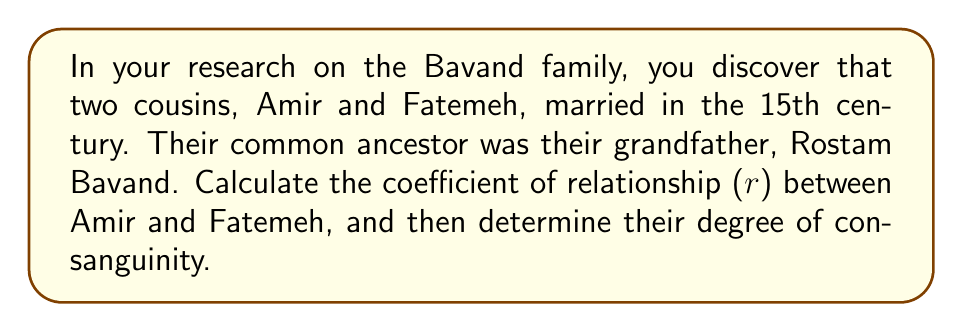Can you solve this math problem? To solve this problem, we'll follow these steps:

1) First, let's calculate the coefficient of relationship (r) between Amir and Fatemeh.

2) The coefficient of relationship is calculated using the formula:

   $$r = \sum (\frac{1}{2})^{n_1 + n_2 + 1}$$

   Where $n_1$ is the number of generations from one individual to the common ancestor, and $n_2$ is the number of generations from the other individual to the common ancestor.

3) In this case, both Amir and Fatemeh are two generations away from their common ancestor (grandfather Rostam Bavand). So $n_1 = n_2 = 2$.

4) Plugging these values into the formula:

   $$r = (\frac{1}{2})^{2 + 2 + 1} = (\frac{1}{2})^5 = \frac{1}{32} = 0.03125$$

5) Now, to determine the degree of consanguinity, we use the canonical method. The degree of consanguinity is the sum of the generations each person is removed from the common ancestor.

6) In this case, it's 2 (Amir to Rostam) + 2 (Fatemeh to Rostam) = 4.

Therefore, Amir and Fatemeh have a coefficient of relationship of 0.03125 and a 4th degree of consanguinity.
Answer: $r = 0.03125$, 4th degree 